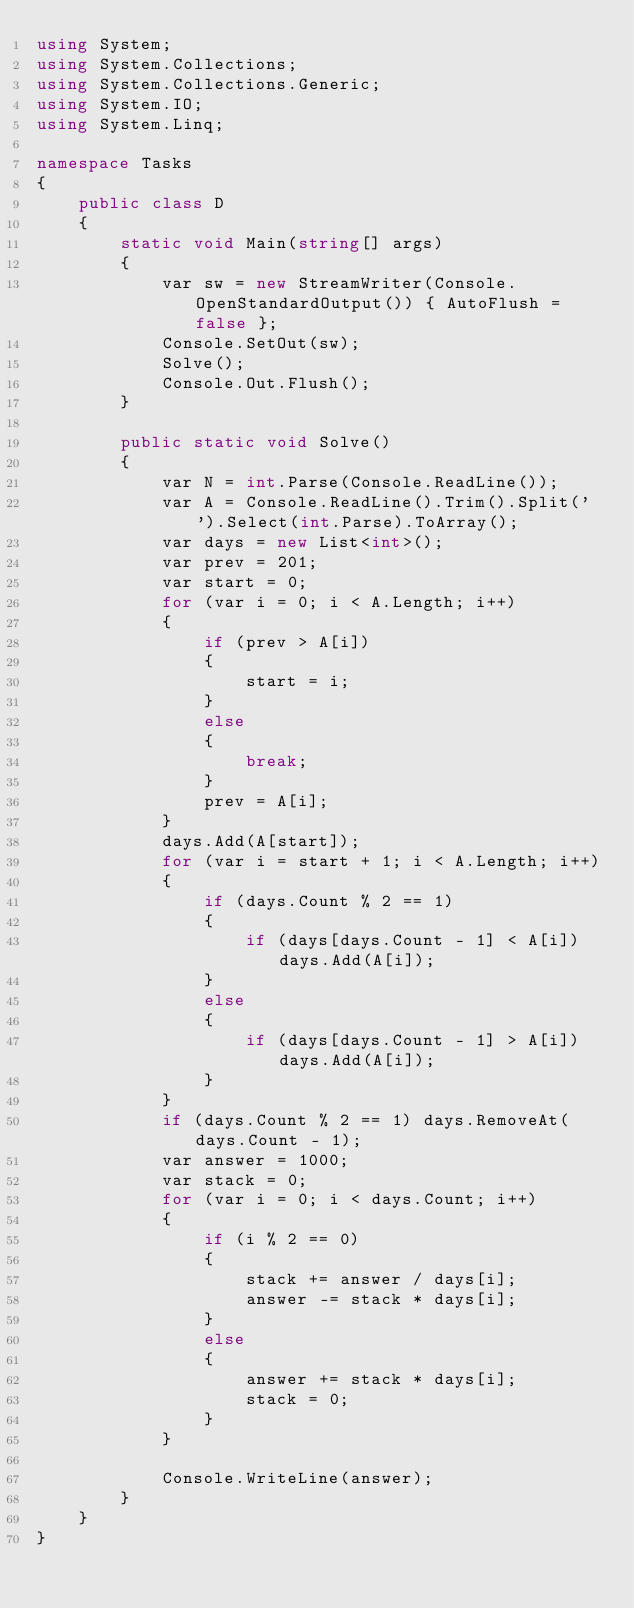<code> <loc_0><loc_0><loc_500><loc_500><_C#_>using System;
using System.Collections;
using System.Collections.Generic;
using System.IO;
using System.Linq;

namespace Tasks
{
    public class D
    {
        static void Main(string[] args)
        {
            var sw = new StreamWriter(Console.OpenStandardOutput()) { AutoFlush = false };
            Console.SetOut(sw);
            Solve();
            Console.Out.Flush();
        }

        public static void Solve()
        {
            var N = int.Parse(Console.ReadLine());
            var A = Console.ReadLine().Trim().Split(' ').Select(int.Parse).ToArray();
            var days = new List<int>();
            var prev = 201;
            var start = 0;
            for (var i = 0; i < A.Length; i++)
            {
                if (prev > A[i])
                {
                    start = i;
                }
                else
                {
                    break;
                }
                prev = A[i];
            }
            days.Add(A[start]);
            for (var i = start + 1; i < A.Length; i++)
            {
                if (days.Count % 2 == 1)
                {
                    if (days[days.Count - 1] < A[i]) days.Add(A[i]);
                }
                else
                {
                    if (days[days.Count - 1] > A[i]) days.Add(A[i]);
                }
            }
            if (days.Count % 2 == 1) days.RemoveAt(days.Count - 1);
            var answer = 1000;
            var stack = 0;
            for (var i = 0; i < days.Count; i++)
            {
                if (i % 2 == 0)
                {
                    stack += answer / days[i];
                    answer -= stack * days[i];
                }
                else
                {
                    answer += stack * days[i];
                    stack = 0;
                }
            }

            Console.WriteLine(answer);
        }
    }
}
</code> 